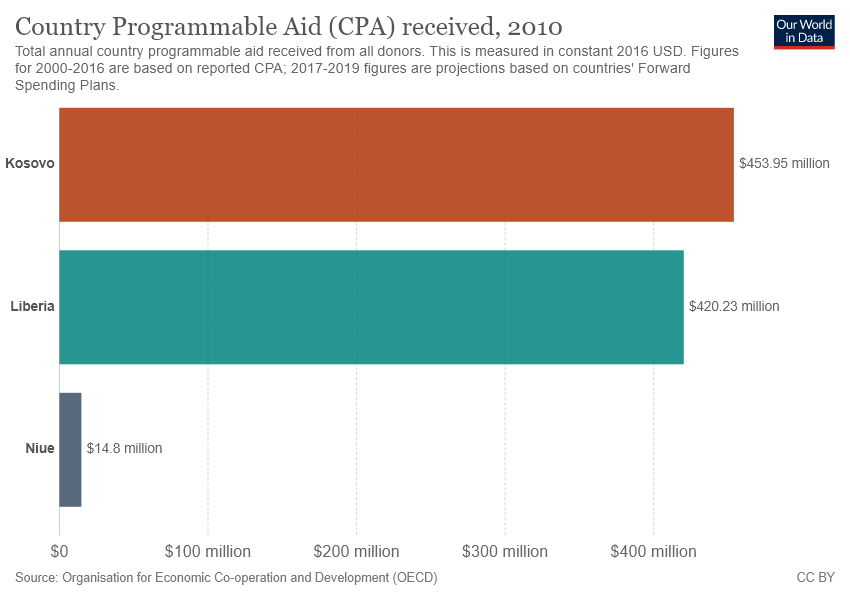Point out several critical features in this image. The name of the middle bar is Liberia. The value of the largest two bars is 33.72... 